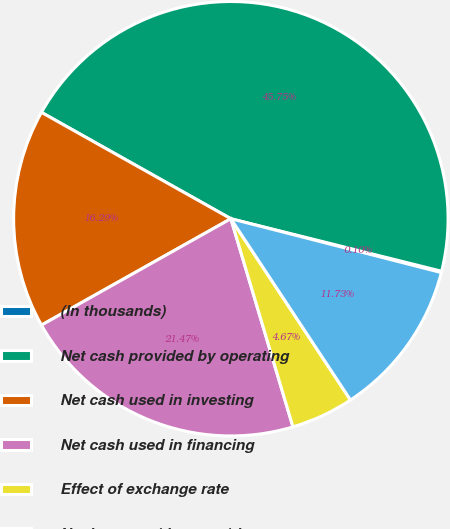Convert chart to OTSL. <chart><loc_0><loc_0><loc_500><loc_500><pie_chart><fcel>(In thousands)<fcel>Net cash provided by operating<fcel>Net cash used in investing<fcel>Net cash used in financing<fcel>Effect of exchange rate<fcel>Net increase (decrease) in<nl><fcel>0.1%<fcel>45.75%<fcel>16.29%<fcel>21.47%<fcel>4.67%<fcel>11.73%<nl></chart> 